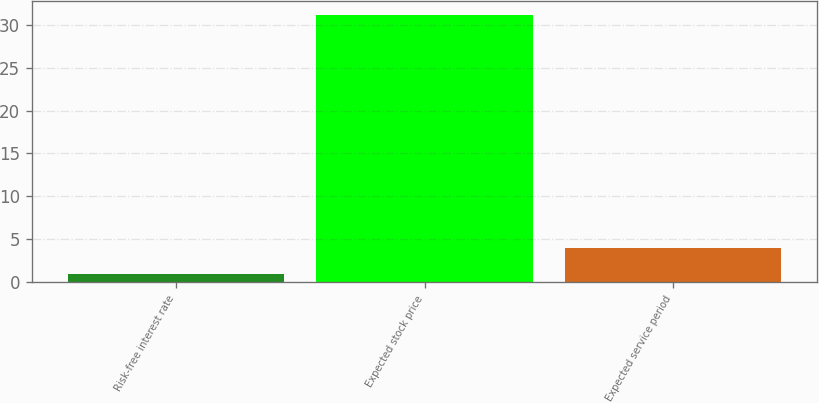Convert chart to OTSL. <chart><loc_0><loc_0><loc_500><loc_500><bar_chart><fcel>Risk-free interest rate<fcel>Expected stock price<fcel>Expected service period<nl><fcel>0.9<fcel>31.2<fcel>3.93<nl></chart> 